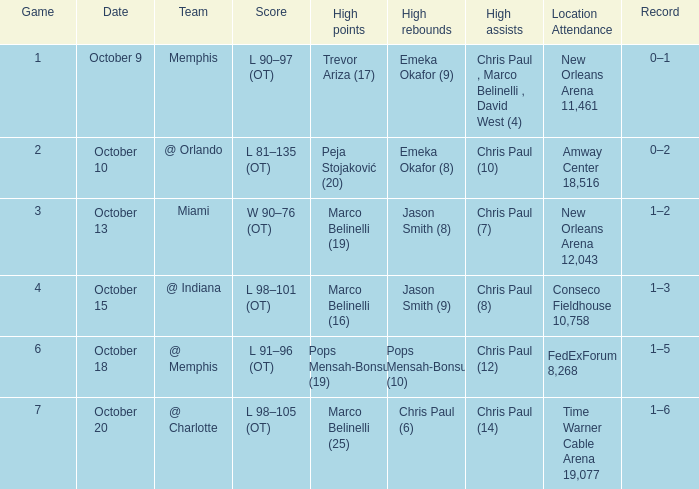What team did the Hornets play in game 4? @ Indiana. 